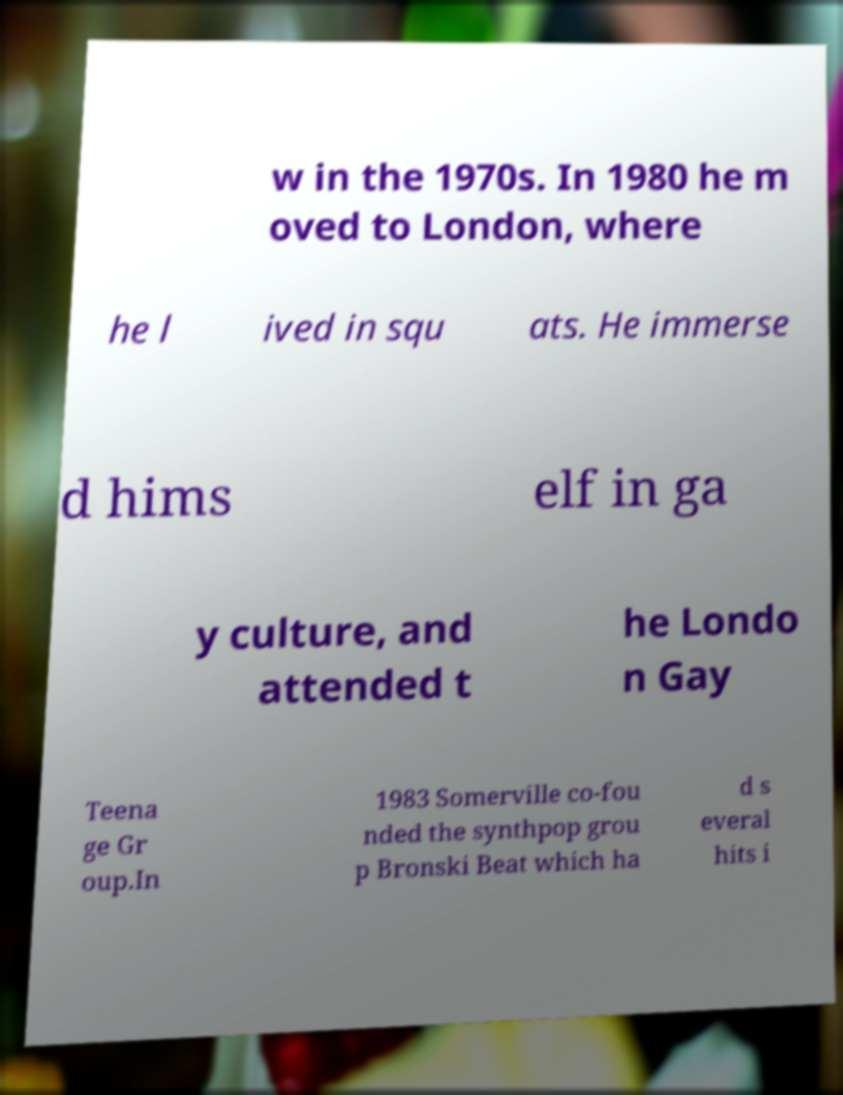Please identify and transcribe the text found in this image. w in the 1970s. In 1980 he m oved to London, where he l ived in squ ats. He immerse d hims elf in ga y culture, and attended t he Londo n Gay Teena ge Gr oup.In 1983 Somerville co-fou nded the synthpop grou p Bronski Beat which ha d s everal hits i 